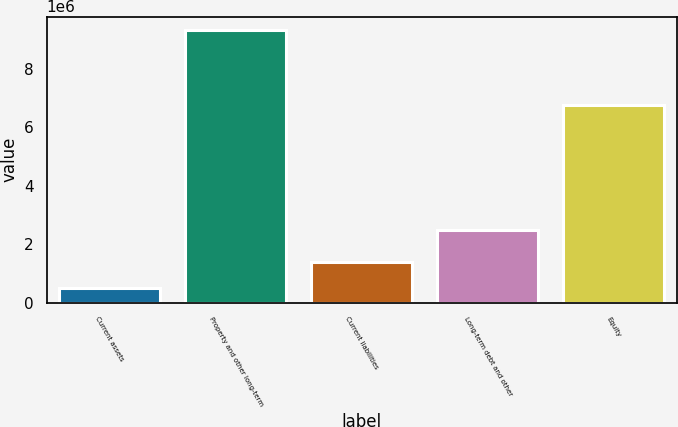Convert chart. <chart><loc_0><loc_0><loc_500><loc_500><bar_chart><fcel>Current assets<fcel>Property and other long-term<fcel>Current liabilities<fcel>Long-term debt and other<fcel>Equity<nl><fcel>502316<fcel>9.33209e+06<fcel>1.38529e+06<fcel>2.50125e+06<fcel>6.76324e+06<nl></chart> 